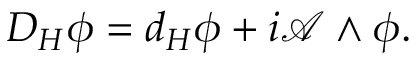Convert formula to latex. <formula><loc_0><loc_0><loc_500><loc_500>D _ { H } \phi = d _ { H } \phi + i { \mathcal { A } } \wedge \phi .</formula> 